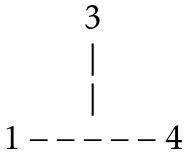<formula> <loc_0><loc_0><loc_500><loc_500>\begin{matrix} 3 \\ | \\ | \\ 1 - - - - - 4 \end{matrix}</formula> 